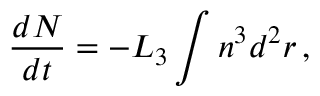Convert formula to latex. <formula><loc_0><loc_0><loc_500><loc_500>\frac { d N } { d t } = - L _ { 3 } \int n ^ { 3 } d ^ { 2 } r \, ,</formula> 